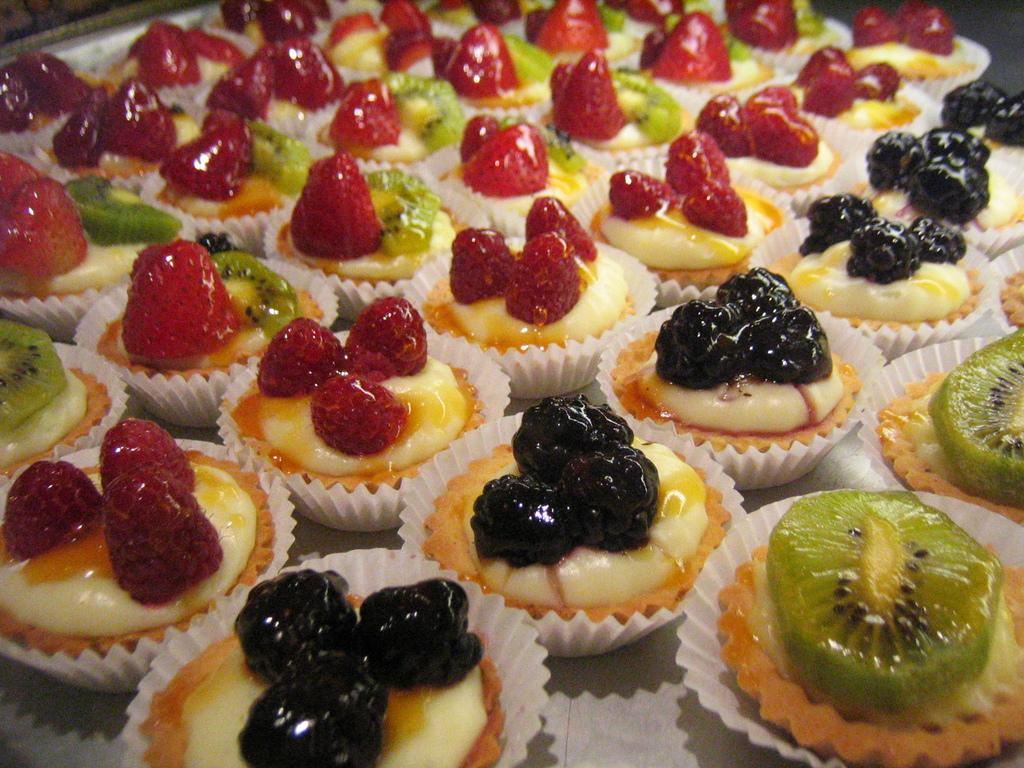What type of dessert can be seen in the image? There are cupcakes in the image. What is on top of the cupcakes? The cupcakes are topped with fruits. Where are the cupcakes located? The cupcakes are placed on a table. How many passengers are visible in the image? There are no passengers present in the image; it features cupcakes topped with fruits on a table. What type of visitor can be seen in the image? There are no visitors present in the image; it features cupcakes topped with fruits on a table. 